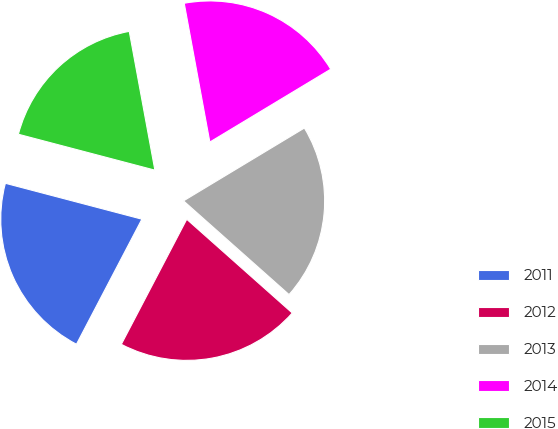Convert chart to OTSL. <chart><loc_0><loc_0><loc_500><loc_500><pie_chart><fcel>2011<fcel>2012<fcel>2013<fcel>2014<fcel>2015<nl><fcel>21.42%<fcel>21.11%<fcel>20.19%<fcel>19.27%<fcel>18.0%<nl></chart> 